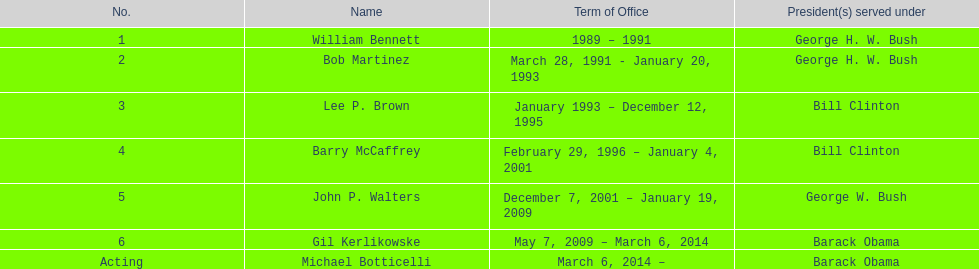Who succeeded lee p. brown as the appointed director? Barry McCaffrey. 